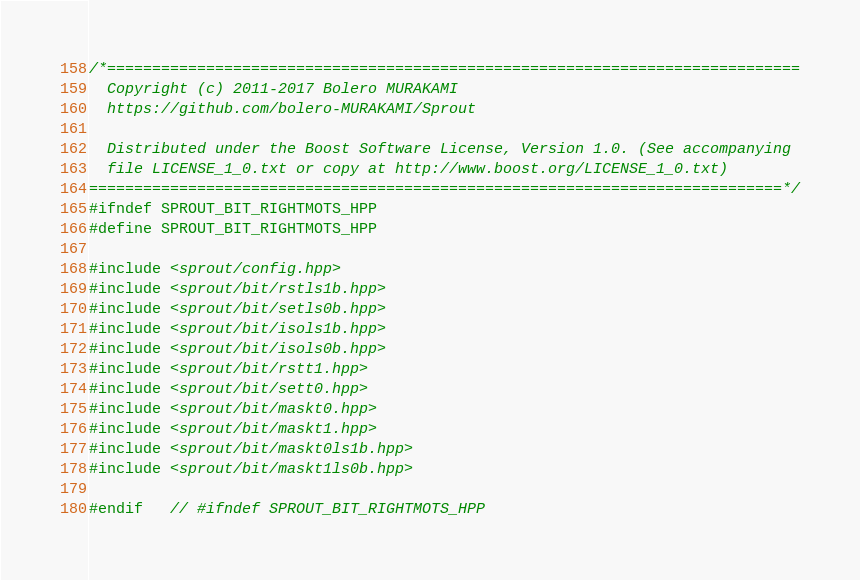<code> <loc_0><loc_0><loc_500><loc_500><_C++_>/*=============================================================================
  Copyright (c) 2011-2017 Bolero MURAKAMI
  https://github.com/bolero-MURAKAMI/Sprout

  Distributed under the Boost Software License, Version 1.0. (See accompanying
  file LICENSE_1_0.txt or copy at http://www.boost.org/LICENSE_1_0.txt)
=============================================================================*/
#ifndef SPROUT_BIT_RIGHTMOTS_HPP
#define SPROUT_BIT_RIGHTMOTS_HPP

#include <sprout/config.hpp>
#include <sprout/bit/rstls1b.hpp>
#include <sprout/bit/setls0b.hpp>
#include <sprout/bit/isols1b.hpp>
#include <sprout/bit/isols0b.hpp>
#include <sprout/bit/rstt1.hpp>
#include <sprout/bit/sett0.hpp>
#include <sprout/bit/maskt0.hpp>
#include <sprout/bit/maskt1.hpp>
#include <sprout/bit/maskt0ls1b.hpp>
#include <sprout/bit/maskt1ls0b.hpp>

#endif	// #ifndef SPROUT_BIT_RIGHTMOTS_HPP
</code> 